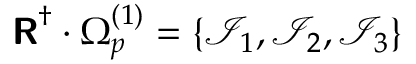<formula> <loc_0><loc_0><loc_500><loc_500>R ^ { \dagger } \cdot \Omega _ { p } ^ { ( 1 ) } = \left \{ \mathcal { I } _ { 1 } , \mathcal { I } _ { 2 } , \mathcal { I } _ { 3 } \right \}</formula> 